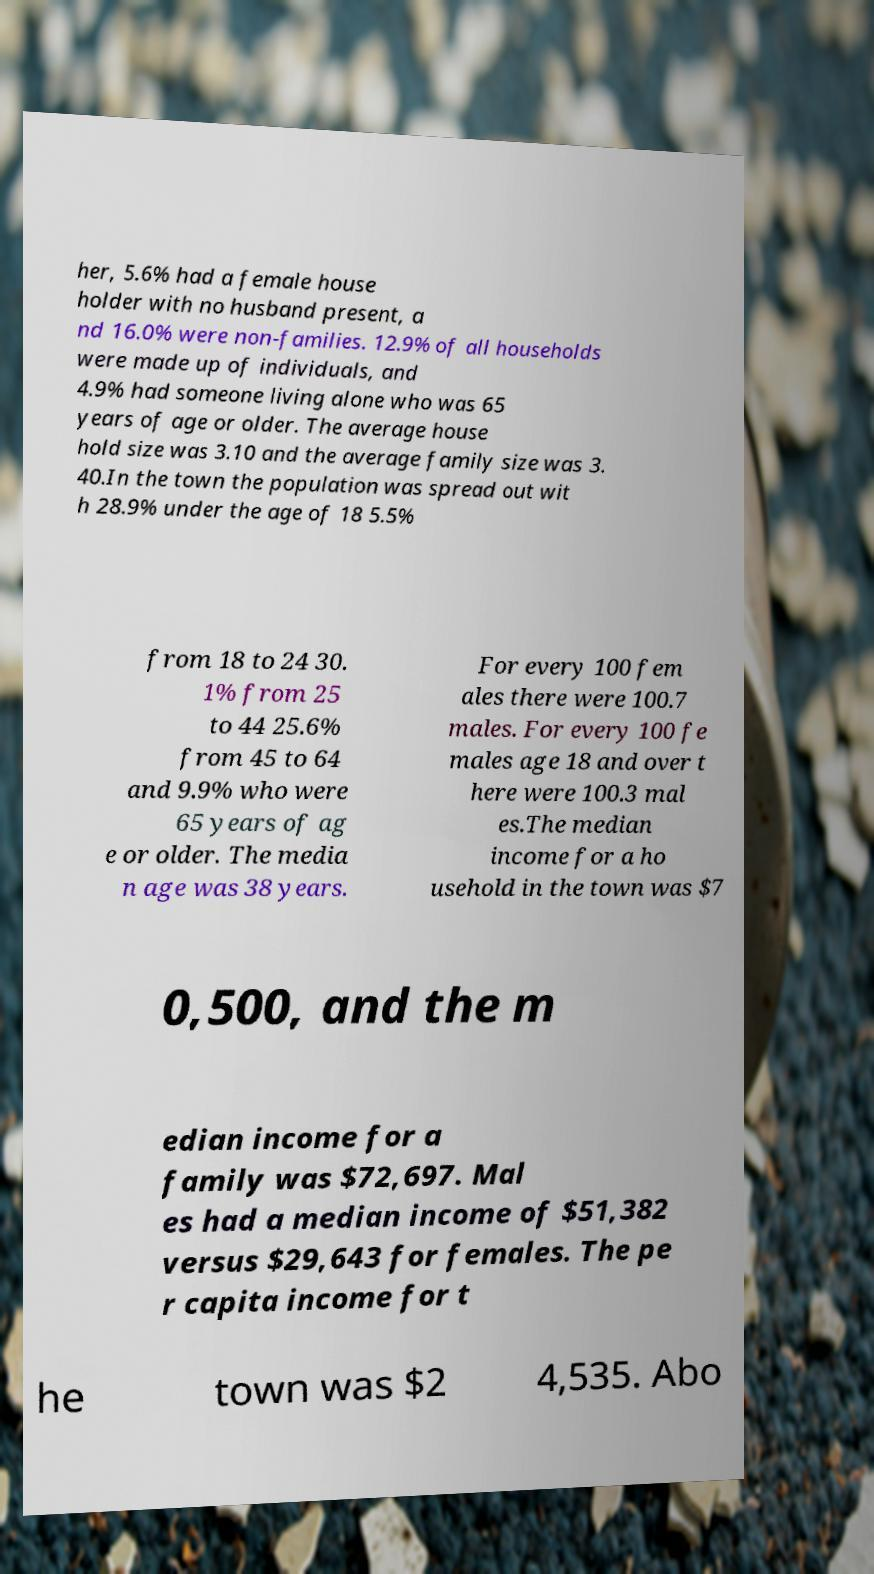Can you accurately transcribe the text from the provided image for me? her, 5.6% had a female house holder with no husband present, a nd 16.0% were non-families. 12.9% of all households were made up of individuals, and 4.9% had someone living alone who was 65 years of age or older. The average house hold size was 3.10 and the average family size was 3. 40.In the town the population was spread out wit h 28.9% under the age of 18 5.5% from 18 to 24 30. 1% from 25 to 44 25.6% from 45 to 64 and 9.9% who were 65 years of ag e or older. The media n age was 38 years. For every 100 fem ales there were 100.7 males. For every 100 fe males age 18 and over t here were 100.3 mal es.The median income for a ho usehold in the town was $7 0,500, and the m edian income for a family was $72,697. Mal es had a median income of $51,382 versus $29,643 for females. The pe r capita income for t he town was $2 4,535. Abo 